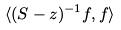<formula> <loc_0><loc_0><loc_500><loc_500>\langle ( S - z ) ^ { - 1 } f , f \rangle</formula> 